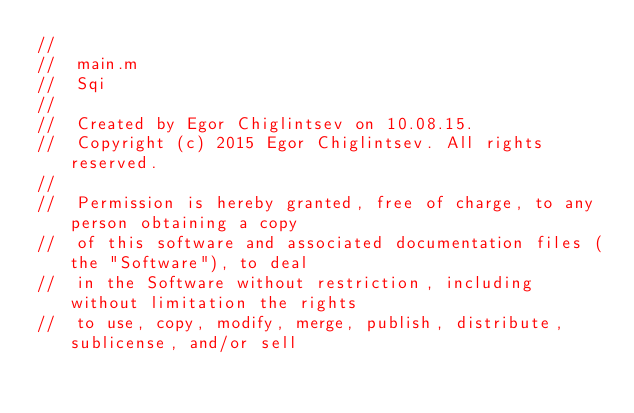Convert code to text. <code><loc_0><loc_0><loc_500><loc_500><_ObjectiveC_>//
//  main.m
//  Sqi
//
//  Created by Egor Chiglintsev on 10.08.15.
//  Copyright (c) 2015 Egor Chiglintsev. All rights reserved.
//
//  Permission is hereby granted, free of charge, to any person obtaining a copy
//  of this software and associated documentation files (the "Software"), to deal
//  in the Software without restriction, including without limitation the rights
//  to use, copy, modify, merge, publish, distribute, sublicense, and/or sell</code> 